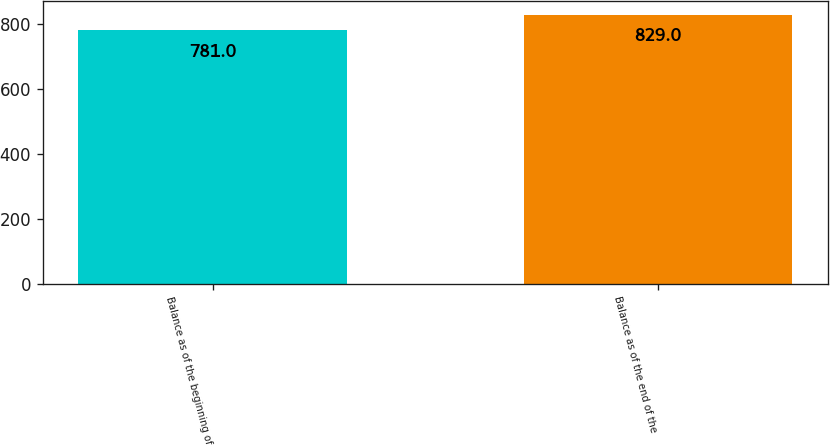Convert chart to OTSL. <chart><loc_0><loc_0><loc_500><loc_500><bar_chart><fcel>Balance as of the beginning of<fcel>Balance as of the end of the<nl><fcel>781<fcel>829<nl></chart> 